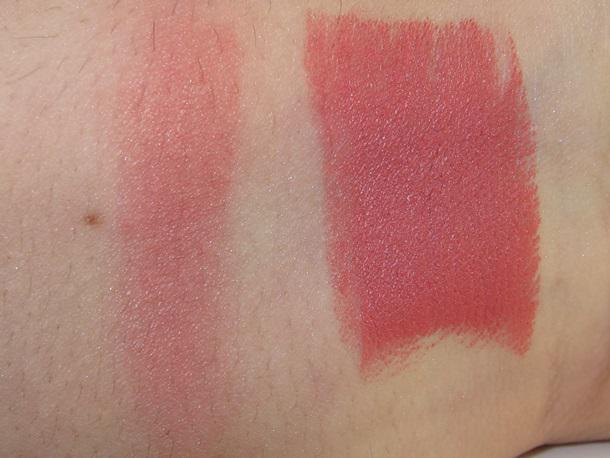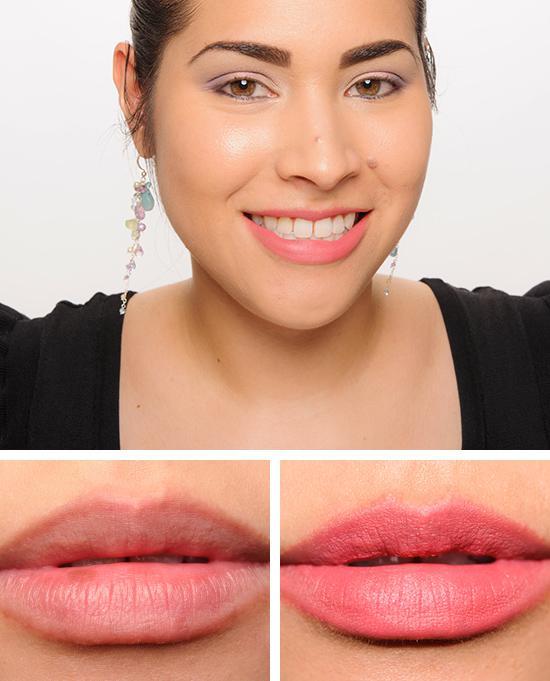The first image is the image on the left, the second image is the image on the right. Evaluate the accuracy of this statement regarding the images: "the left image has flat topped lipstick". Is it true? Answer yes or no. No. The first image is the image on the left, the second image is the image on the right. Evaluate the accuracy of this statement regarding the images: "The withdrawn lipstick tube in the left image has a flat top.". Is it true? Answer yes or no. No. 